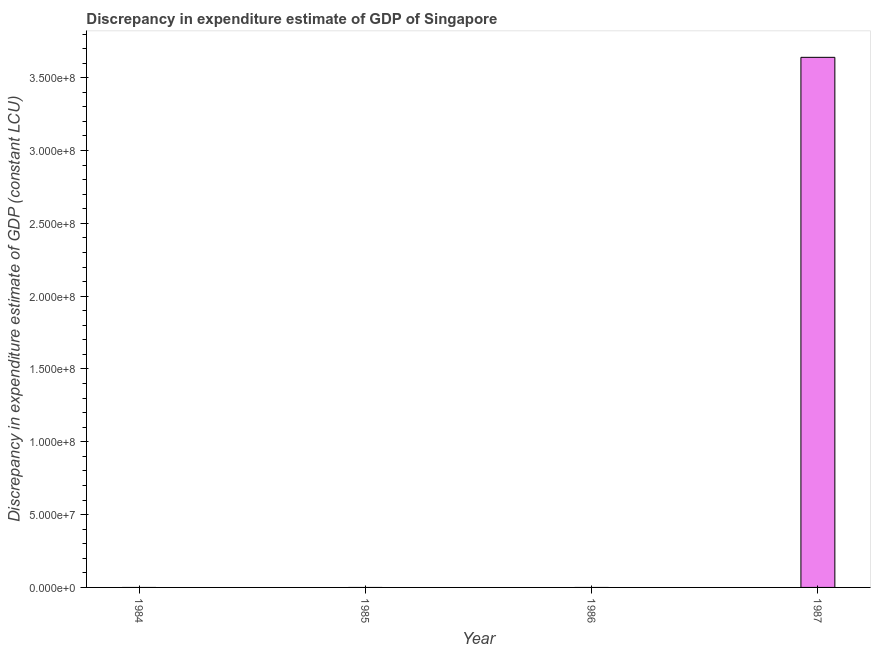What is the title of the graph?
Your answer should be very brief. Discrepancy in expenditure estimate of GDP of Singapore. What is the label or title of the X-axis?
Provide a succinct answer. Year. What is the label or title of the Y-axis?
Offer a terse response. Discrepancy in expenditure estimate of GDP (constant LCU). What is the discrepancy in expenditure estimate of gdp in 1985?
Keep it short and to the point. 0. Across all years, what is the maximum discrepancy in expenditure estimate of gdp?
Offer a very short reply. 3.64e+08. Across all years, what is the minimum discrepancy in expenditure estimate of gdp?
Keep it short and to the point. 0. In which year was the discrepancy in expenditure estimate of gdp maximum?
Ensure brevity in your answer.  1987. What is the sum of the discrepancy in expenditure estimate of gdp?
Ensure brevity in your answer.  3.64e+08. What is the average discrepancy in expenditure estimate of gdp per year?
Your answer should be compact. 9.10e+07. What is the difference between the highest and the lowest discrepancy in expenditure estimate of gdp?
Your response must be concise. 3.64e+08. In how many years, is the discrepancy in expenditure estimate of gdp greater than the average discrepancy in expenditure estimate of gdp taken over all years?
Make the answer very short. 1. How many bars are there?
Keep it short and to the point. 1. What is the Discrepancy in expenditure estimate of GDP (constant LCU) in 1985?
Keep it short and to the point. 0. What is the Discrepancy in expenditure estimate of GDP (constant LCU) of 1986?
Your response must be concise. 0. What is the Discrepancy in expenditure estimate of GDP (constant LCU) in 1987?
Your answer should be very brief. 3.64e+08. 